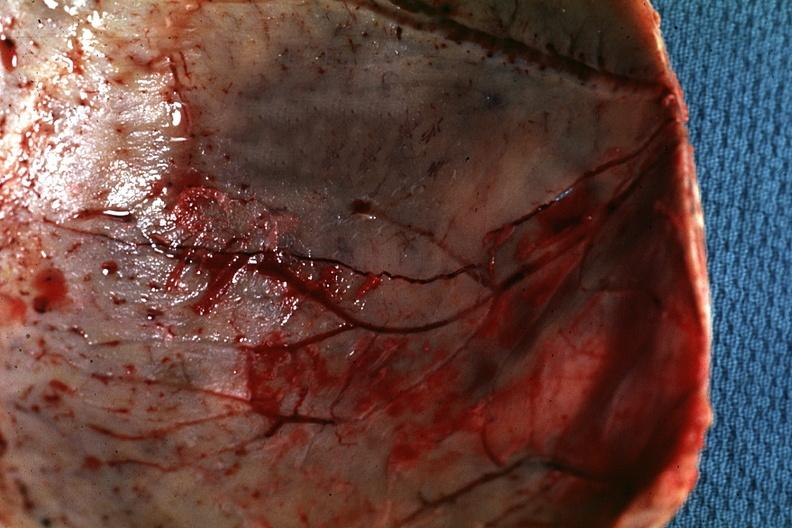s glomerulosa present?
Answer the question using a single word or phrase. No 